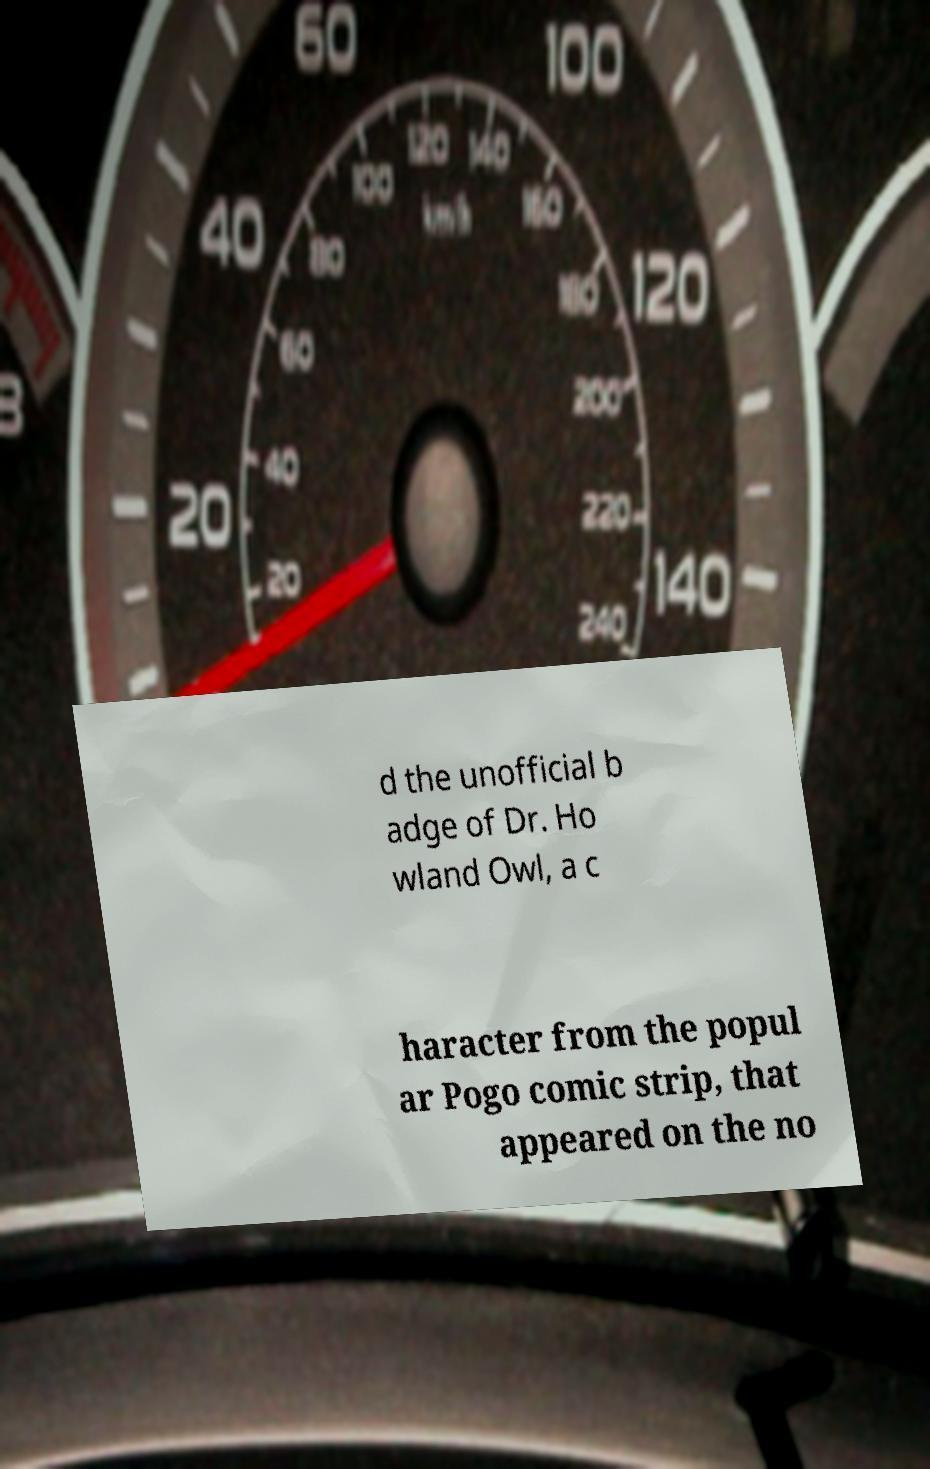For documentation purposes, I need the text within this image transcribed. Could you provide that? d the unofficial b adge of Dr. Ho wland Owl, a c haracter from the popul ar Pogo comic strip, that appeared on the no 